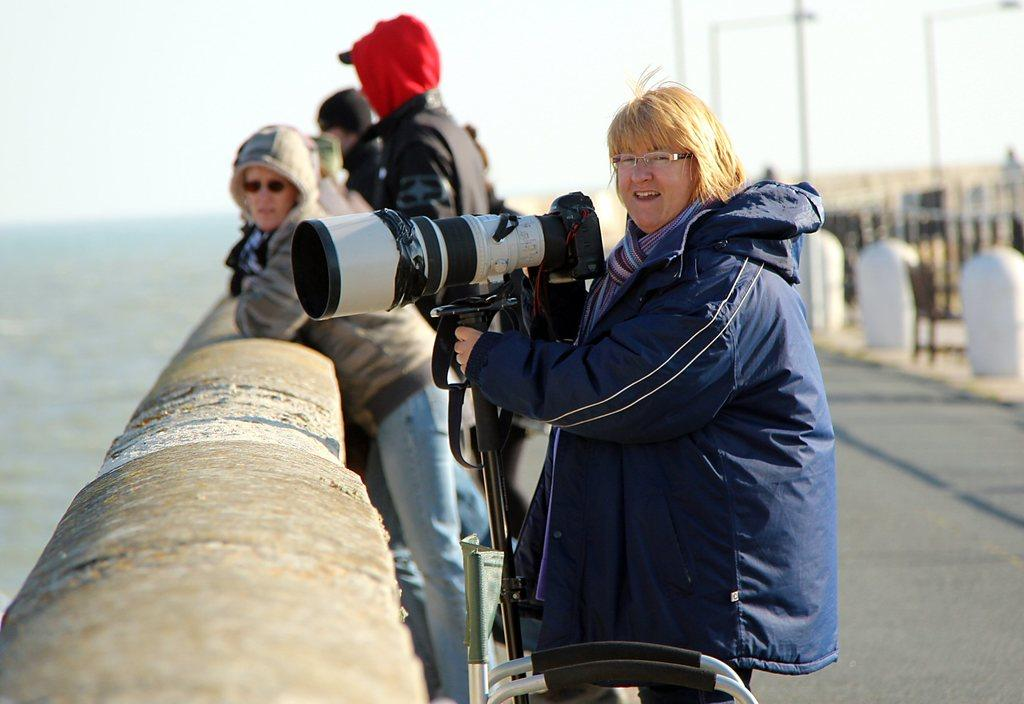Who is the main subject in the image? There is a woman in the image. What is the woman holding in the image? The woman is holding a camera. Can you describe the people in the background of the image? There are people standing in the background of the image. What is in front of the woman in the image? There is a small wall in front of the woman. How would you describe the background of the image? The background of the image is blurred. How many snakes are slithering around the woman's feet in the image? There are no snakes present in the image; the woman is standing near a small wall. 